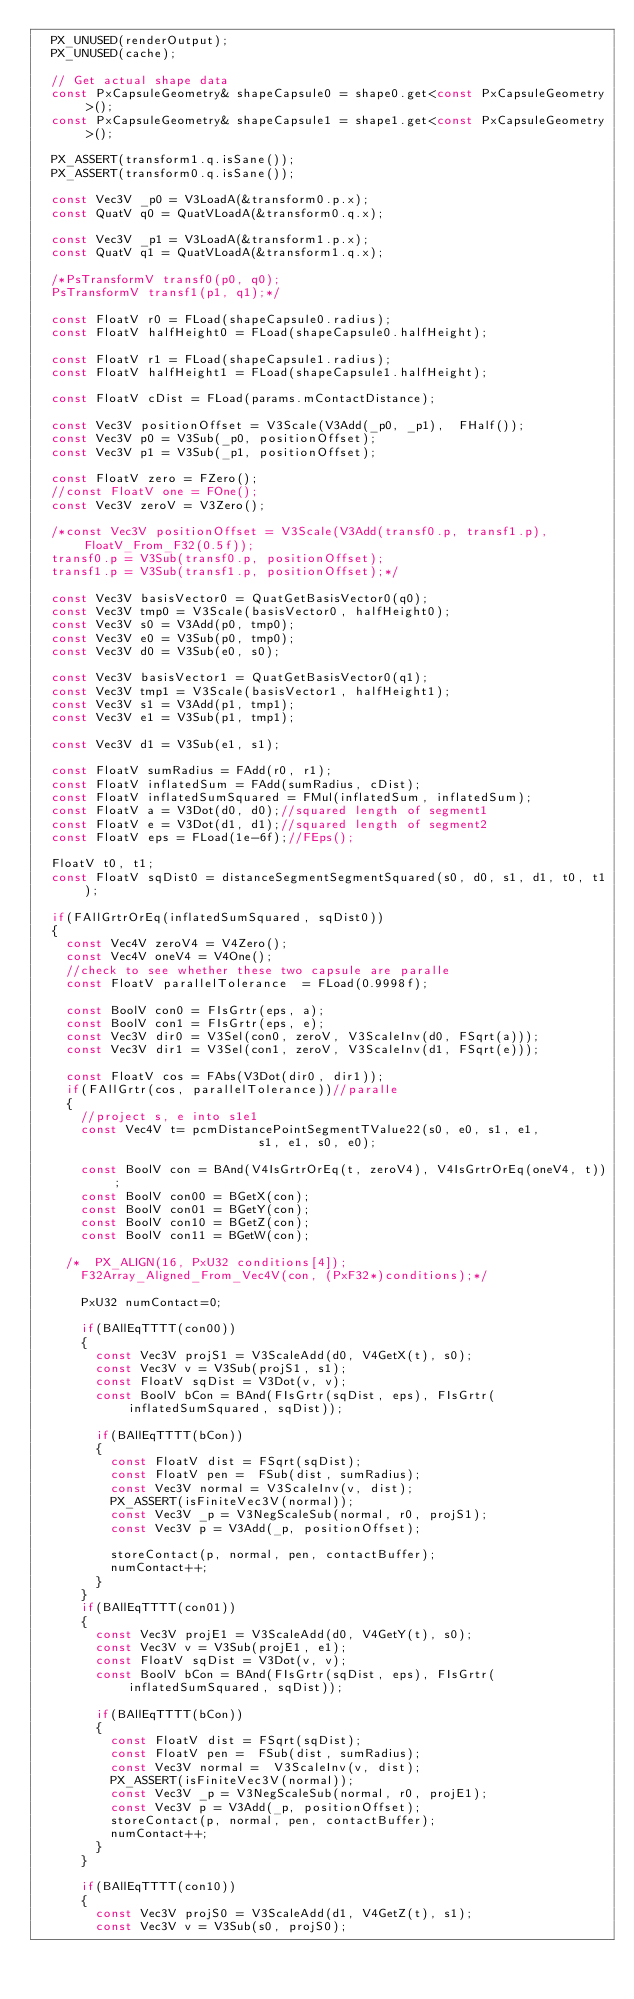<code> <loc_0><loc_0><loc_500><loc_500><_C++_>	PX_UNUSED(renderOutput);
	PX_UNUSED(cache);

	// Get actual shape data
	const PxCapsuleGeometry& shapeCapsule0 = shape0.get<const PxCapsuleGeometry>();
	const PxCapsuleGeometry& shapeCapsule1 = shape1.get<const PxCapsuleGeometry>();

	PX_ASSERT(transform1.q.isSane());
	PX_ASSERT(transform0.q.isSane());

	const Vec3V _p0 = V3LoadA(&transform0.p.x);
	const QuatV q0 = QuatVLoadA(&transform0.q.x);

	const Vec3V _p1 = V3LoadA(&transform1.p.x);
	const QuatV q1 = QuatVLoadA(&transform1.q.x);

	/*PsTransformV transf0(p0, q0);
	PsTransformV transf1(p1, q1);*/
	
	const FloatV r0 = FLoad(shapeCapsule0.radius);
	const FloatV halfHeight0 = FLoad(shapeCapsule0.halfHeight);

	const FloatV r1 = FLoad(shapeCapsule1.radius);
	const FloatV halfHeight1 = FLoad(shapeCapsule1.halfHeight);

	const FloatV cDist = FLoad(params.mContactDistance);

	const Vec3V positionOffset = V3Scale(V3Add(_p0, _p1),  FHalf());
	const Vec3V p0 = V3Sub(_p0, positionOffset);
	const Vec3V p1 = V3Sub(_p1, positionOffset);

	const FloatV zero = FZero();
	//const FloatV one = FOne();
	const Vec3V zeroV = V3Zero();

	/*const Vec3V positionOffset = V3Scale(V3Add(transf0.p, transf1.p), FloatV_From_F32(0.5f));
	transf0.p = V3Sub(transf0.p, positionOffset);
	transf1.p = V3Sub(transf1.p, positionOffset);*/

	const Vec3V basisVector0 = QuatGetBasisVector0(q0);
	const Vec3V tmp0 = V3Scale(basisVector0, halfHeight0);
	const Vec3V s0 = V3Add(p0, tmp0);
	const Vec3V e0 = V3Sub(p0, tmp0);
	const Vec3V d0 = V3Sub(e0, s0);

	const Vec3V basisVector1 = QuatGetBasisVector0(q1);
	const Vec3V tmp1 = V3Scale(basisVector1, halfHeight1);
	const Vec3V s1 = V3Add(p1, tmp1);
	const Vec3V e1 = V3Sub(p1, tmp1); 

	const Vec3V d1 = V3Sub(e1, s1);

	const FloatV sumRadius = FAdd(r0, r1);
	const FloatV inflatedSum = FAdd(sumRadius, cDist);
	const FloatV inflatedSumSquared = FMul(inflatedSum, inflatedSum);
	const FloatV a = V3Dot(d0, d0);//squared length of segment1
	const FloatV e = V3Dot(d1, d1);//squared length of segment2
	const FloatV eps = FLoad(1e-6f);//FEps();

	FloatV t0, t1;
	const FloatV sqDist0 = distanceSegmentSegmentSquared(s0, d0, s1, d1, t0, t1);

	if(FAllGrtrOrEq(inflatedSumSquared, sqDist0))
	{
		const Vec4V zeroV4 = V4Zero();
		const Vec4V oneV4 = V4One();
		//check to see whether these two capsule are paralle
		const FloatV parallelTolerance  = FLoad(0.9998f);
		
		const BoolV con0 = FIsGrtr(eps, a);
		const BoolV con1 = FIsGrtr(eps, e);
		const Vec3V dir0 = V3Sel(con0, zeroV, V3ScaleInv(d0, FSqrt(a)));
		const Vec3V dir1 = V3Sel(con1, zeroV, V3ScaleInv(d1, FSqrt(e)));

		const FloatV cos = FAbs(V3Dot(dir0, dir1));
		if(FAllGrtr(cos, parallelTolerance))//paralle
		{
			//project s, e into s1e1
			const Vec4V t= pcmDistancePointSegmentTValue22(s0, e0, s1, e1,
															s1, e1, s0, e0);

			const BoolV con = BAnd(V4IsGrtrOrEq(t, zeroV4), V4IsGrtrOrEq(oneV4, t));
			const BoolV con00 = BGetX(con);
			const BoolV con01 = BGetY(con);
			const BoolV con10 = BGetZ(con);
			const BoolV con11 = BGetW(con);

		/*	PX_ALIGN(16, PxU32 conditions[4]);
			F32Array_Aligned_From_Vec4V(con, (PxF32*)conditions);*/
		
			PxU32 numContact=0;

			if(BAllEqTTTT(con00))
			{
				const Vec3V projS1 = V3ScaleAdd(d0, V4GetX(t), s0);
				const Vec3V v = V3Sub(projS1, s1);
				const FloatV sqDist = V3Dot(v, v);
				const BoolV bCon = BAnd(FIsGrtr(sqDist, eps), FIsGrtr(inflatedSumSquared, sqDist));
				
				if(BAllEqTTTT(bCon))
				{
					const FloatV dist = FSqrt(sqDist);
					const FloatV pen =  FSub(dist, sumRadius);
					const Vec3V normal = V3ScaleInv(v, dist);
					PX_ASSERT(isFiniteVec3V(normal));
					const Vec3V _p = V3NegScaleSub(normal, r0, projS1);
					const Vec3V p = V3Add(_p, positionOffset);
					
					storeContact(p, normal, pen, contactBuffer);
					numContact++;
				}
			}
			if(BAllEqTTTT(con01))
			{
				const Vec3V projE1 = V3ScaleAdd(d0, V4GetY(t), s0);
				const Vec3V v = V3Sub(projE1, e1);
				const FloatV sqDist = V3Dot(v, v);
				const BoolV bCon = BAnd(FIsGrtr(sqDist, eps), FIsGrtr(inflatedSumSquared, sqDist));
				
				if(BAllEqTTTT(bCon))
				{
					const FloatV dist = FSqrt(sqDist);
					const FloatV pen =  FSub(dist, sumRadius);
					const Vec3V normal =  V3ScaleInv(v, dist);
					PX_ASSERT(isFiniteVec3V(normal));
					const Vec3V _p = V3NegScaleSub(normal, r0, projE1);
					const Vec3V p = V3Add(_p, positionOffset);
					storeContact(p, normal, pen, contactBuffer);
					numContact++;
				}
			}

			if(BAllEqTTTT(con10))
			{
				const Vec3V projS0 = V3ScaleAdd(d1, V4GetZ(t), s1);
				const Vec3V v = V3Sub(s0, projS0);</code> 